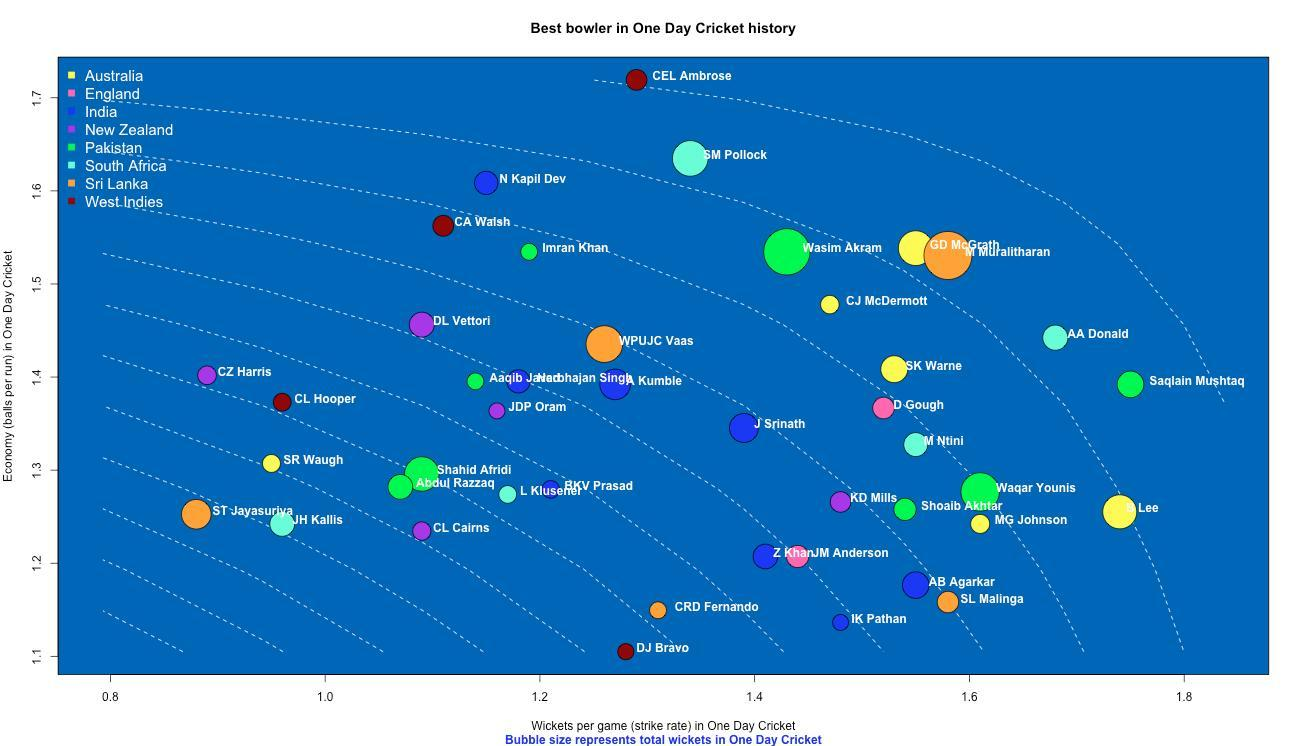Which Pakistan bowler has taken the highest number of wickets in one day cricket?
Answer the question with a short phrase. Wasim Akram Which Indian bowler has taken the highest number of wickets in one day cricket? A Kumble Which South African bowler has the highest strike rate in one-day cricket? AA Donald Which Sri Lankan bowler has taken the highest number of wickets in one day cricket? M Muralitharan Which Australian bowler has the highest strike rate in one-day cricket? Lee 